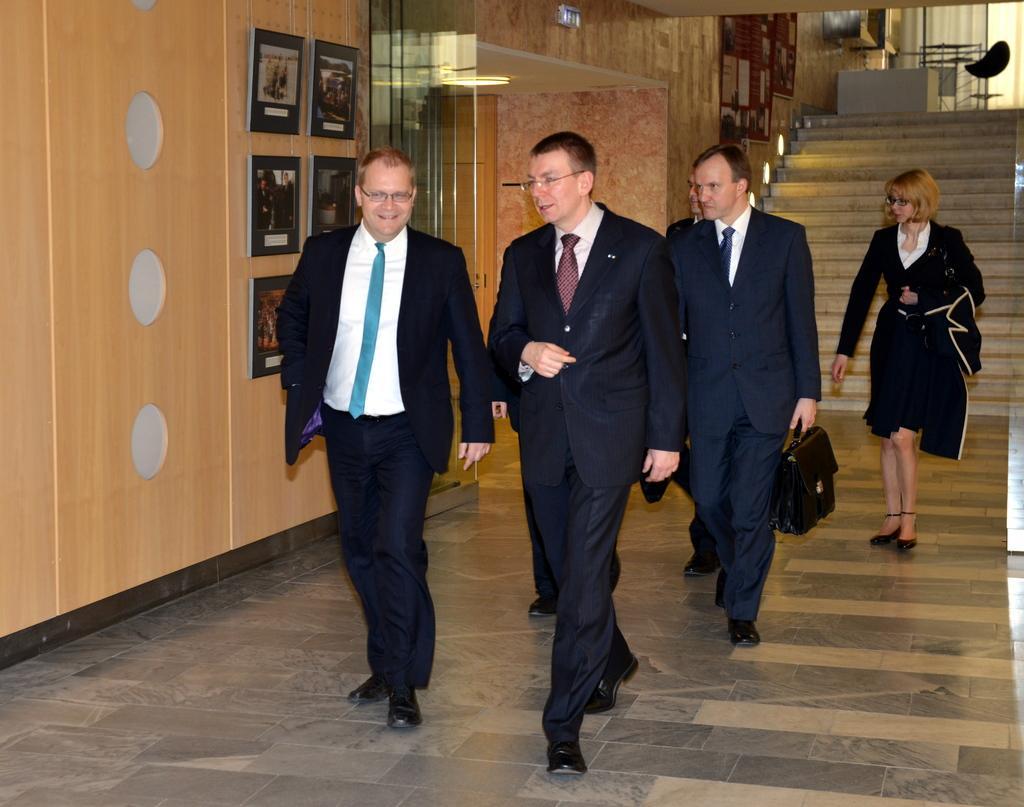Could you give a brief overview of what you see in this image? In this picture we can see a group of people walking on the floor, steps, frames on the wall and in the background we can see a chair, windows with curtains. 